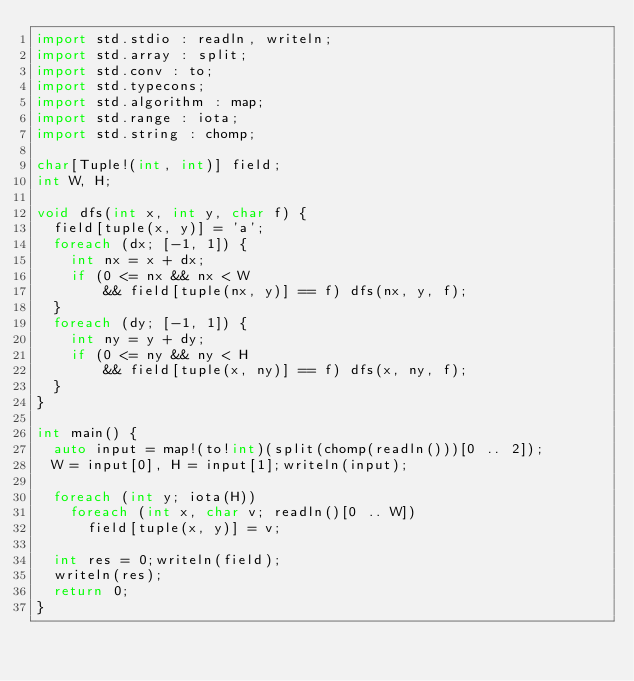<code> <loc_0><loc_0><loc_500><loc_500><_D_>import std.stdio : readln, writeln;
import std.array : split;
import std.conv : to;
import std.typecons;
import std.algorithm : map;
import std.range : iota;
import std.string : chomp;

char[Tuple!(int, int)] field;
int W, H;

void dfs(int x, int y, char f) {
  field[tuple(x, y)] = 'a';
  foreach (dx; [-1, 1]) {
    int nx = x + dx;
    if (0 <= nx && nx < W
        && field[tuple(nx, y)] == f) dfs(nx, y, f);
  }
  foreach (dy; [-1, 1]) {
    int ny = y + dy;
    if (0 <= ny && ny < H
        && field[tuple(x, ny)] == f) dfs(x, ny, f);
  }
}

int main() {
  auto input = map!(to!int)(split(chomp(readln()))[0 .. 2]);
  W = input[0], H = input[1];writeln(input);
  
  foreach (int y; iota(H))
    foreach (int x, char v; readln()[0 .. W])
      field[tuple(x, y)] = v;

  int res = 0;writeln(field);
  writeln(res);
  return 0;
}</code> 